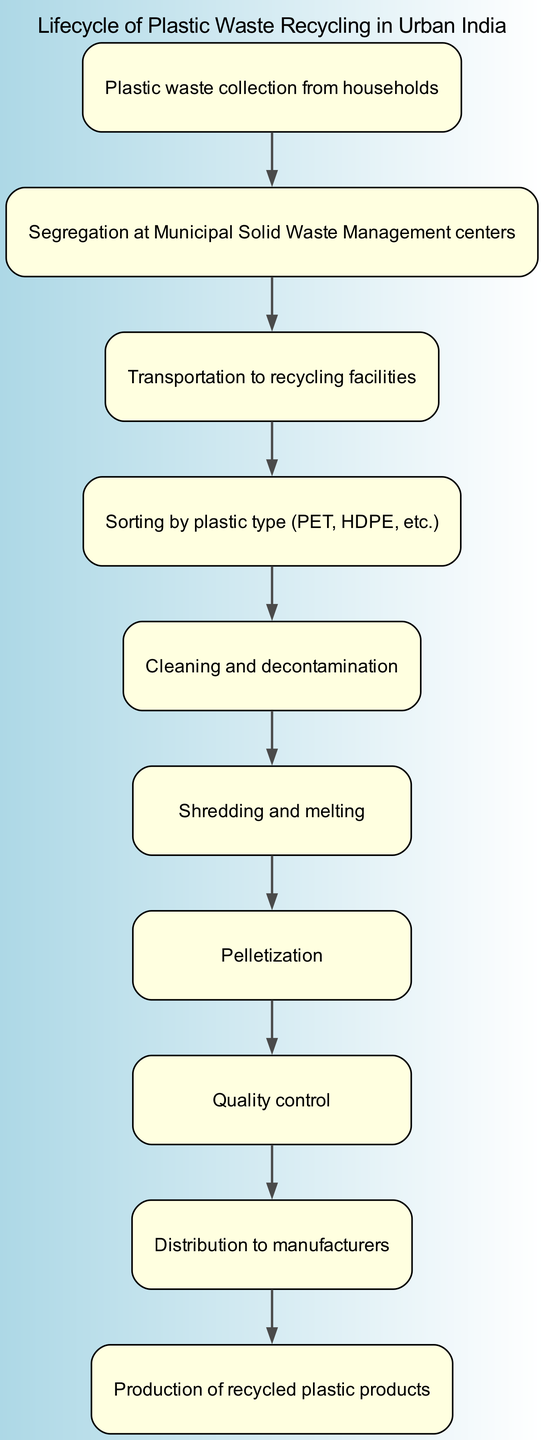What is the first step in the recycling lifecycle? The first step is stated in the first node of the diagram, which says "Plastic waste collection from households."
Answer: Plastic waste collection from households How many total steps are there in the diagram? By counting the nodes of the flowchart, we can determine there are 10 steps listed in the recycling lifecycle.
Answer: 10 What comes after "Sorting by plastic type"? Following "Sorting by plastic type," the next node states "Cleaning and decontamination," indicating the immediate step that follows.
Answer: Cleaning and decontamination Which step involves transportation? The step that specifies transportation is correctly indicated in the third node: "Transportation to recycling facilities," which describes the movement of waste to recycling sites.
Answer: Transportation to recycling facilities What is the last stage of the recycling process? The last stage is defined in the final node of the diagram, which mentions "Production of recycled plastic products," representing the end of the recycling cycle.
Answer: Production of recycled plastic products What step immediately follows "Pelletization"? According to the flow of the diagram, the step that follows "Pelletization" is "Quality control," indicating an essential quality check before distribution.
Answer: Quality control How many steps are involved from collection to production? By examining the flowchart starting from the initial step to the final products, all the intermediary processes result in a total of 10 distinct steps.
Answer: 10 Which step addresses cleaning concerns? The "Cleaning and decontamination" step specifically addresses any contamination issues related to plastic waste before further processing.
Answer: Cleaning and decontamination What type of diagram is being analyzed? The diagram is a flow chart specifically laid out to show the lifecycle of plastic waste recycling in an urban Indian context, detailing various instructions.
Answer: Flow chart 